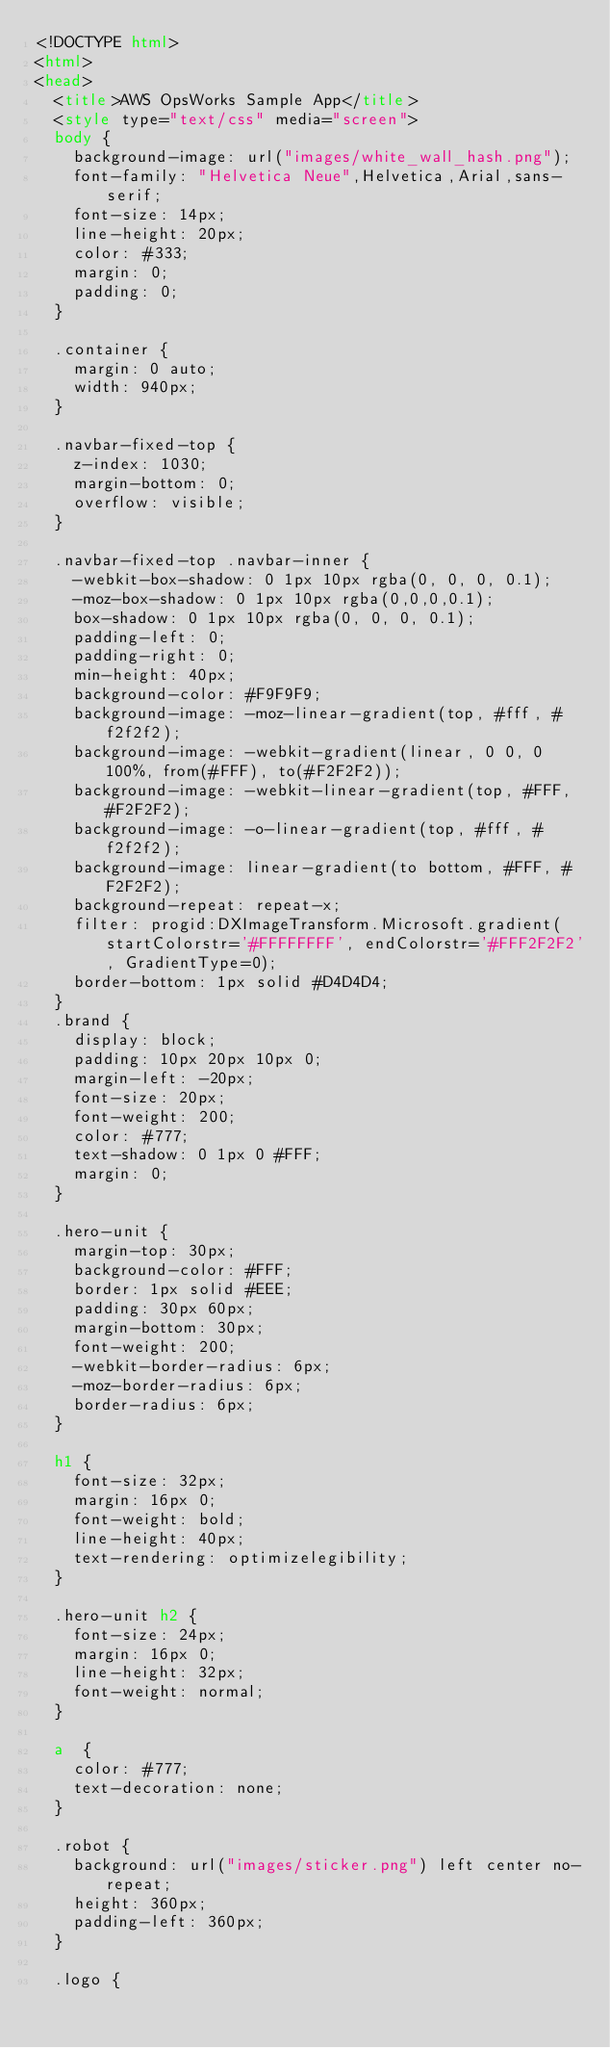Convert code to text. <code><loc_0><loc_0><loc_500><loc_500><_HTML_><!DOCTYPE html>
<html>
<head>
  <title>AWS OpsWorks Sample App</title>
  <style type="text/css" media="screen">
  body {
    background-image: url("images/white_wall_hash.png");
    font-family: "Helvetica Neue",Helvetica,Arial,sans-serif;
    font-size: 14px;
    line-height: 20px;
    color: #333;
    margin: 0;
    padding: 0;
  }

  .container {
    margin: 0 auto;
    width: 940px;
  }

  .navbar-fixed-top {
    z-index: 1030;
    margin-bottom: 0;
    overflow: visible;
  }

  .navbar-fixed-top .navbar-inner {
    -webkit-box-shadow: 0 1px 10px rgba(0, 0, 0, 0.1);
    -moz-box-shadow: 0 1px 10px rgba(0,0,0,0.1);
    box-shadow: 0 1px 10px rgba(0, 0, 0, 0.1);
    padding-left: 0;
    padding-right: 0;
    min-height: 40px;
    background-color: #F9F9F9;
    background-image: -moz-linear-gradient(top, #fff, #f2f2f2);
    background-image: -webkit-gradient(linear, 0 0, 0 100%, from(#FFF), to(#F2F2F2));
    background-image: -webkit-linear-gradient(top, #FFF, #F2F2F2);
    background-image: -o-linear-gradient(top, #fff, #f2f2f2);
    background-image: linear-gradient(to bottom, #FFF, #F2F2F2);
    background-repeat: repeat-x;
    filter: progid:DXImageTransform.Microsoft.gradient(startColorstr='#FFFFFFFF', endColorstr='#FFF2F2F2', GradientType=0);
    border-bottom: 1px solid #D4D4D4;
  }
  .brand {
    display: block;
    padding: 10px 20px 10px 0;
    margin-left: -20px;
    font-size: 20px;
    font-weight: 200;
    color: #777;
    text-shadow: 0 1px 0 #FFF;
    margin: 0;
  }

  .hero-unit {
    margin-top: 30px;
    background-color: #FFF;
    border: 1px solid #EEE;
    padding: 30px 60px;
    margin-bottom: 30px;
    font-weight: 200;
    -webkit-border-radius: 6px;
    -moz-border-radius: 6px;
    border-radius: 6px;
  }

  h1 {
    font-size: 32px;
    margin: 16px 0;
    font-weight: bold;
    line-height: 40px;
    text-rendering: optimizelegibility;
  }

  .hero-unit h2 {
    font-size: 24px;
    margin: 16px 0;
    line-height: 32px;
    font-weight: normal;
  }

  a  {
    color: #777;
    text-decoration: none;
  }

  .robot {
    background: url("images/sticker.png") left center no-repeat;
    height: 360px;
    padding-left: 360px;
  }

  .logo {</code> 